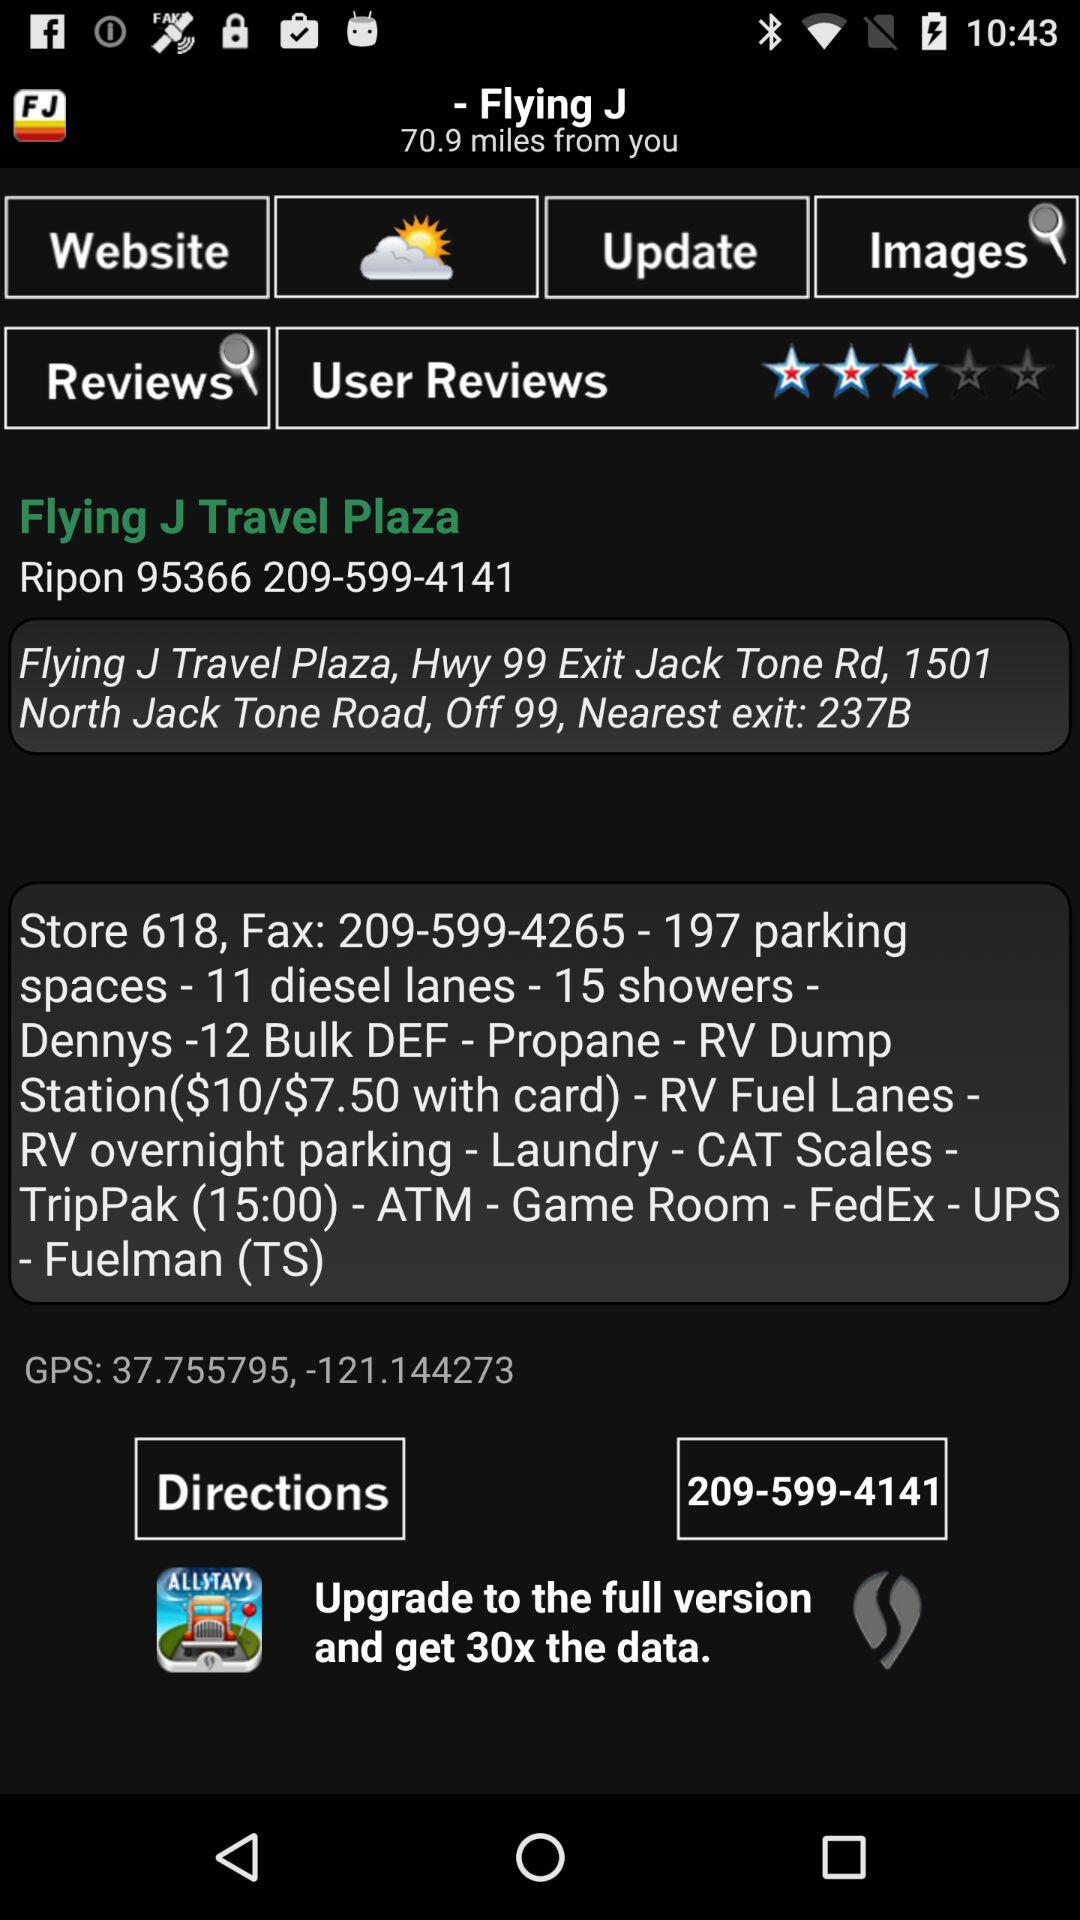What is the rating given by the users? The rating given by the users is 3 stars. 